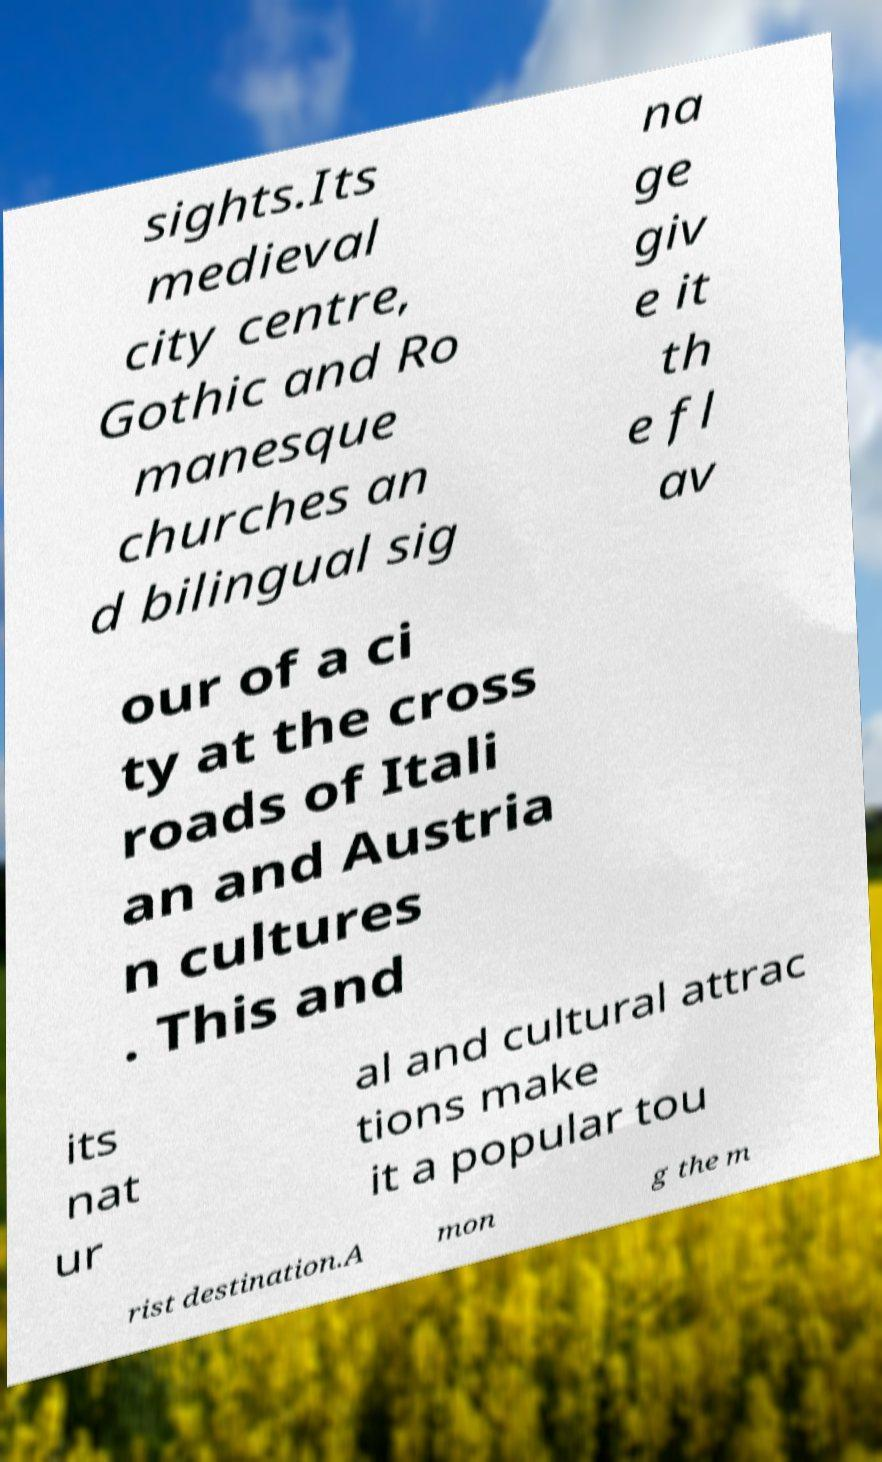For documentation purposes, I need the text within this image transcribed. Could you provide that? sights.Its medieval city centre, Gothic and Ro manesque churches an d bilingual sig na ge giv e it th e fl av our of a ci ty at the cross roads of Itali an and Austria n cultures . This and its nat ur al and cultural attrac tions make it a popular tou rist destination.A mon g the m 